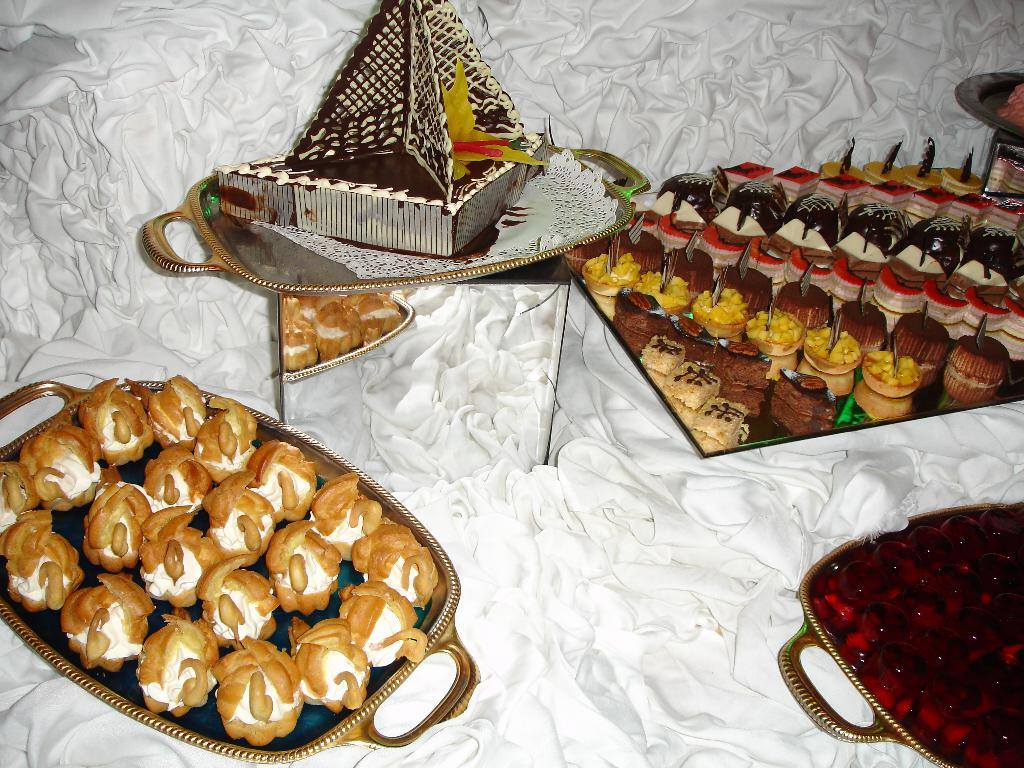What is present on the white cloth in the image? There are many trays with food in the image. What color is the cloth on which the trays are placed? The cloth is white in color. How would you describe the appearance of the food items on the trays? The food items are colorful. What type of stitch is used to hold the plant on the edge of the table in the image? There is no plant or stitch present in the image. 